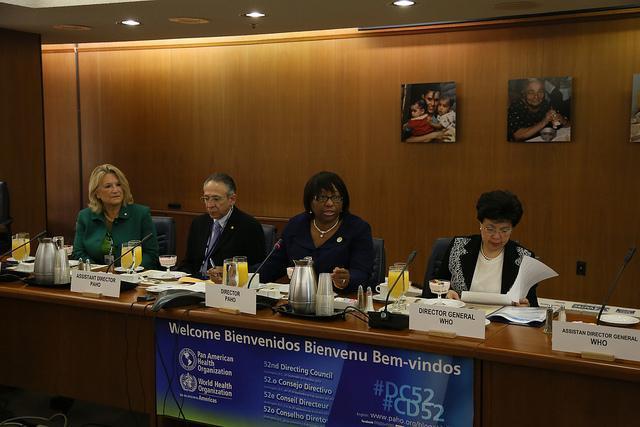How many people are shown?
Give a very brief answer. 4. How many people are in the image?
Give a very brief answer. 4. How many people can you see?
Give a very brief answer. 5. How many horses are there?
Give a very brief answer. 0. 